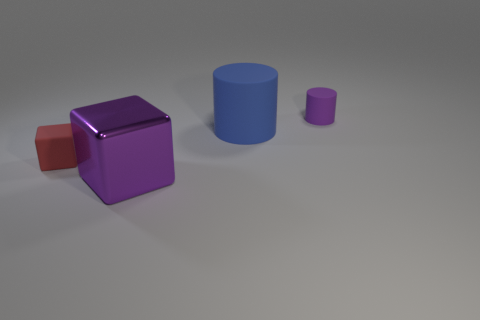Is there a cylinder of the same color as the large cube?
Offer a very short reply. Yes. There is a thing that is both right of the small red block and left of the blue thing; what is it made of?
Make the answer very short. Metal. Does the purple object behind the shiny thing have the same size as the big block?
Your answer should be very brief. No. What is the material of the tiny purple object?
Give a very brief answer. Rubber. There is a tiny object that is in front of the small matte cylinder; what color is it?
Offer a very short reply. Red. How many large objects are either red matte spheres or purple cylinders?
Ensure brevity in your answer.  0. Does the big metallic object that is left of the big blue matte cylinder have the same color as the tiny object right of the large rubber object?
Give a very brief answer. Yes. How many other things are the same color as the small cylinder?
Offer a terse response. 1. What number of red objects are blocks or matte cylinders?
Your answer should be compact. 1. Do the purple metal thing and the rubber object that is on the left side of the large matte cylinder have the same shape?
Your answer should be compact. Yes. 